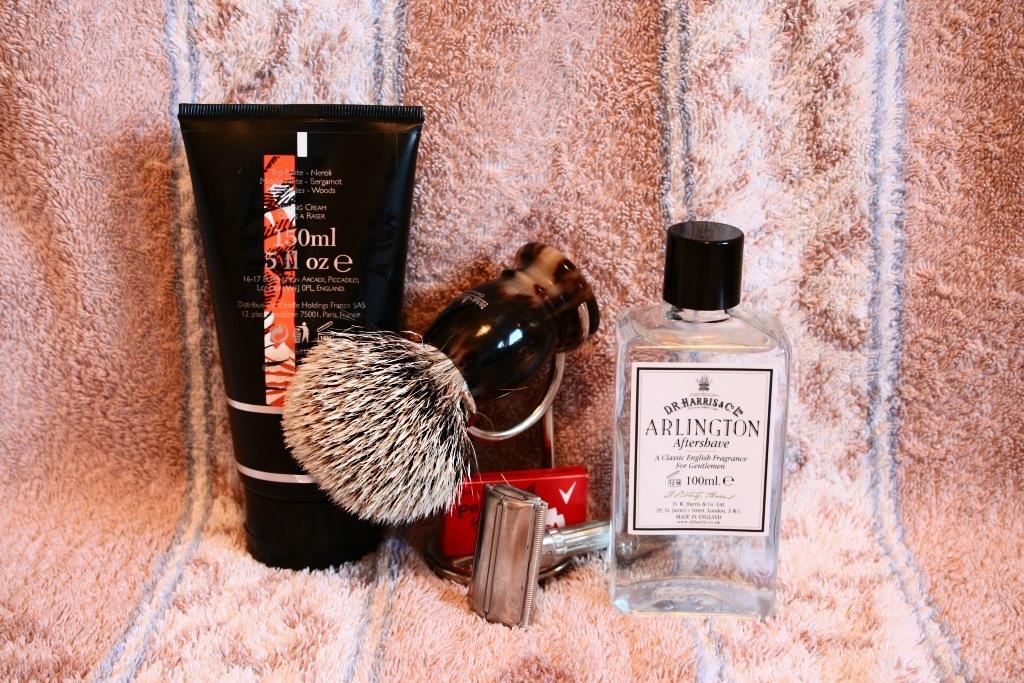How many ml of the lotion are there?
Provide a succinct answer. 150. What brand is the aftershave on the right?
Your answer should be compact. Arlington. 